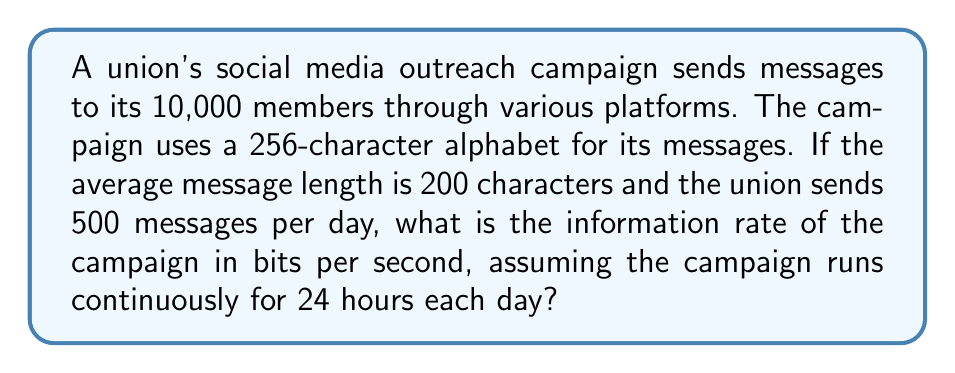Teach me how to tackle this problem. To solve this problem, we need to follow these steps:

1. Calculate the information content of each message:
   The alphabet size is 256 characters, so we can represent each character with 8 bits (as $2^8 = 256$).
   Information content per message = $200 \text{ characters} \times 8 \text{ bits/character} = 1600 \text{ bits}$

2. Calculate the total information sent per day:
   $\text{Total information} = 500 \text{ messages/day} \times 1600 \text{ bits/message} = 800,000 \text{ bits/day}$

3. Convert days to seconds:
   $24 \text{ hours/day} \times 3600 \text{ seconds/hour} = 86,400 \text{ seconds/day}$

4. Calculate the information rate:
   $$\text{Information rate} = \frac{\text{Total information per day}}{\text{Seconds per day}}$$

   $$\text{Information rate} = \frac{800,000 \text{ bits/day}}{86,400 \text{ seconds/day}} \approx 9.26 \text{ bits/second}$$

This rate represents the average number of bits transmitted per second by the union's social media outreach campaign.
Answer: The information rate of the union's social media outreach campaign is approximately 9.26 bits per second. 